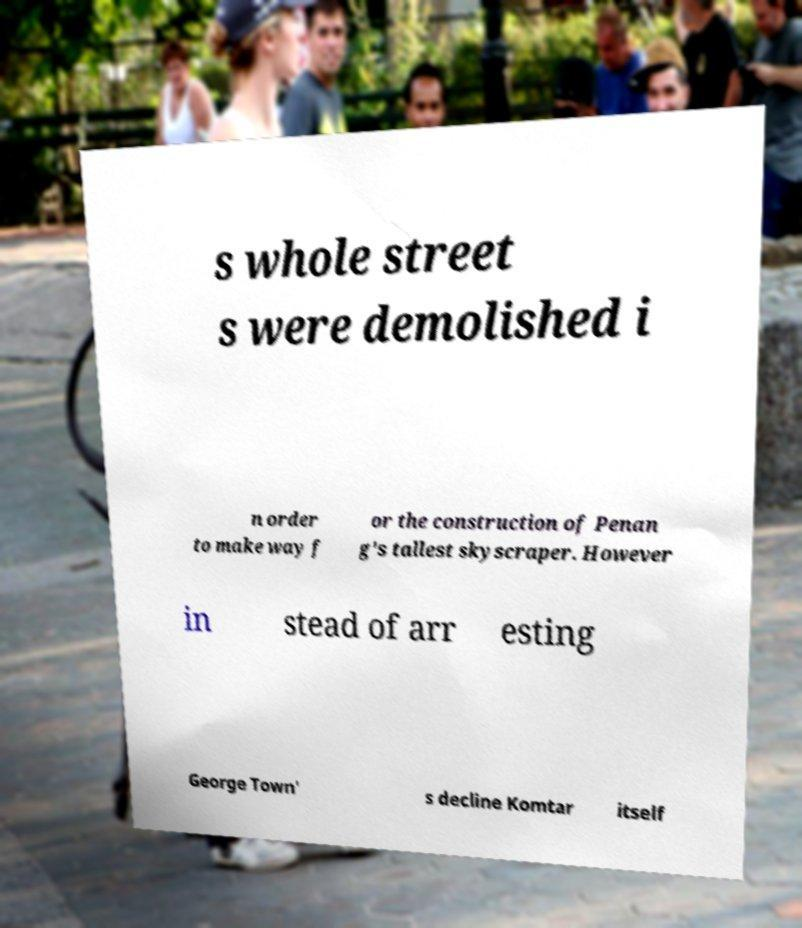I need the written content from this picture converted into text. Can you do that? s whole street s were demolished i n order to make way f or the construction of Penan g's tallest skyscraper. However in stead of arr esting George Town' s decline Komtar itself 